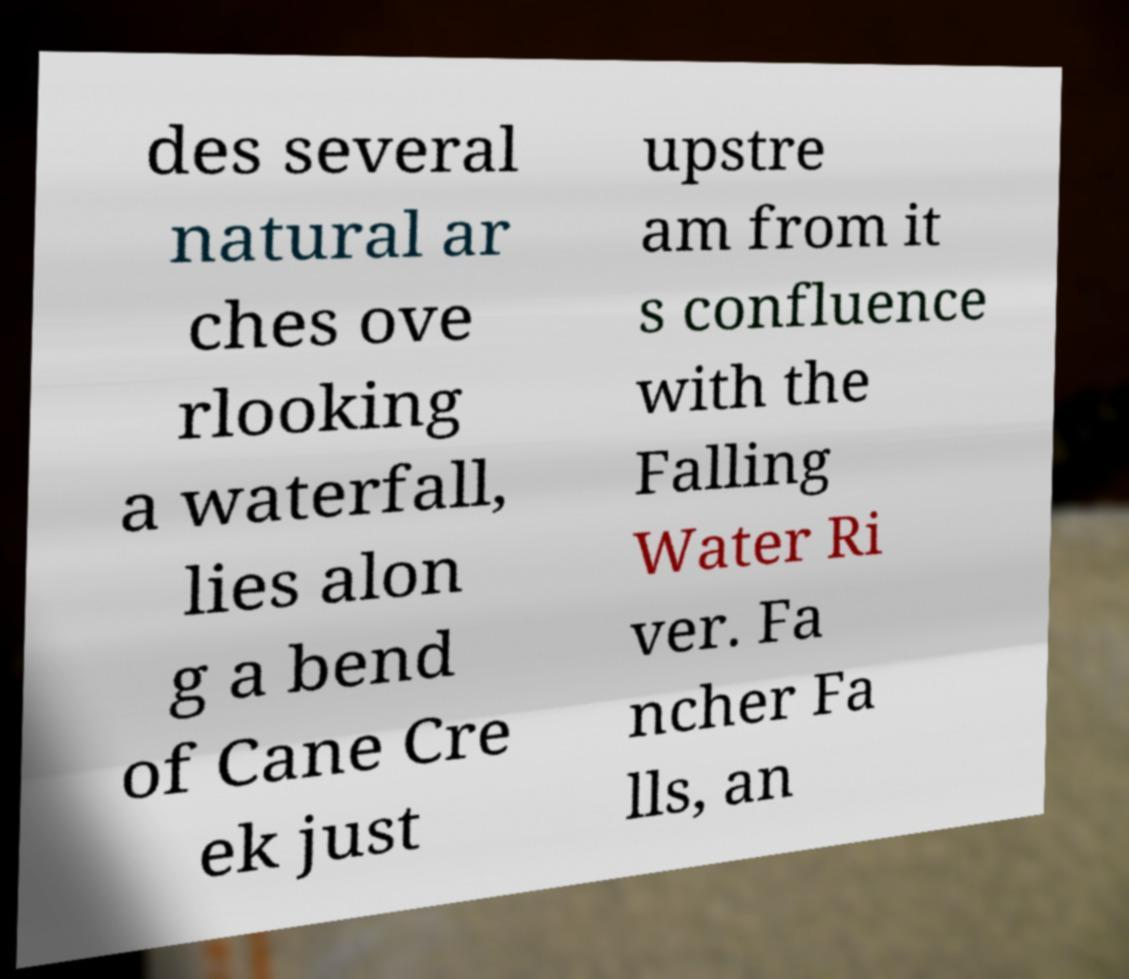Can you read and provide the text displayed in the image?This photo seems to have some interesting text. Can you extract and type it out for me? des several natural ar ches ove rlooking a waterfall, lies alon g a bend of Cane Cre ek just upstre am from it s confluence with the Falling Water Ri ver. Fa ncher Fa lls, an 